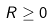Convert formula to latex. <formula><loc_0><loc_0><loc_500><loc_500>R \geq 0</formula> 